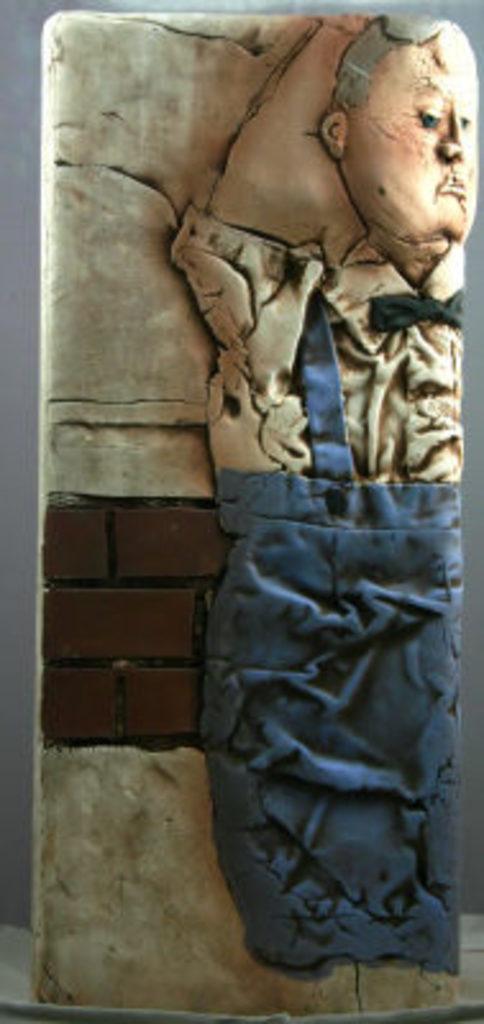How would you summarize this image in a sentence or two? In this image, there is a sculpture carved on a stone, and there are some color on it. 